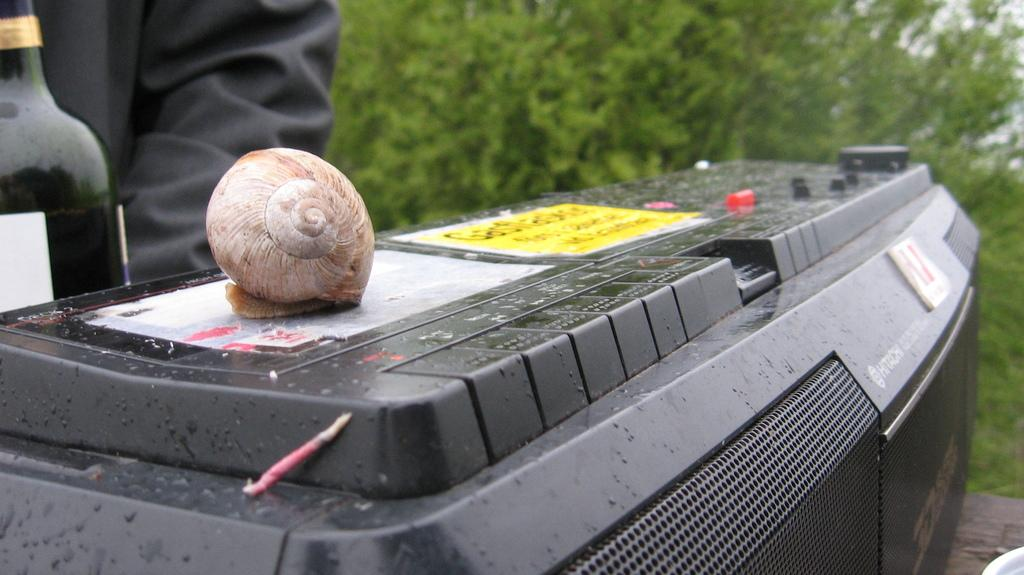What is placed on top of the tape recorder in the image? There is a shell on a tape recorder in the image. What can be seen on the left side of the image? There is a bottle on the left side of the image. What type of vegetation is visible in the background of the image? There are plants in the background of the image. What is the health status of the person on stage in the image? There is no person on stage in the image, and therefore no health status can be determined. How does the shell affect the hearing of the tape recorder in the image? The shell does not affect the hearing of the tape recorder in the image; it is simply placed on top of it. 